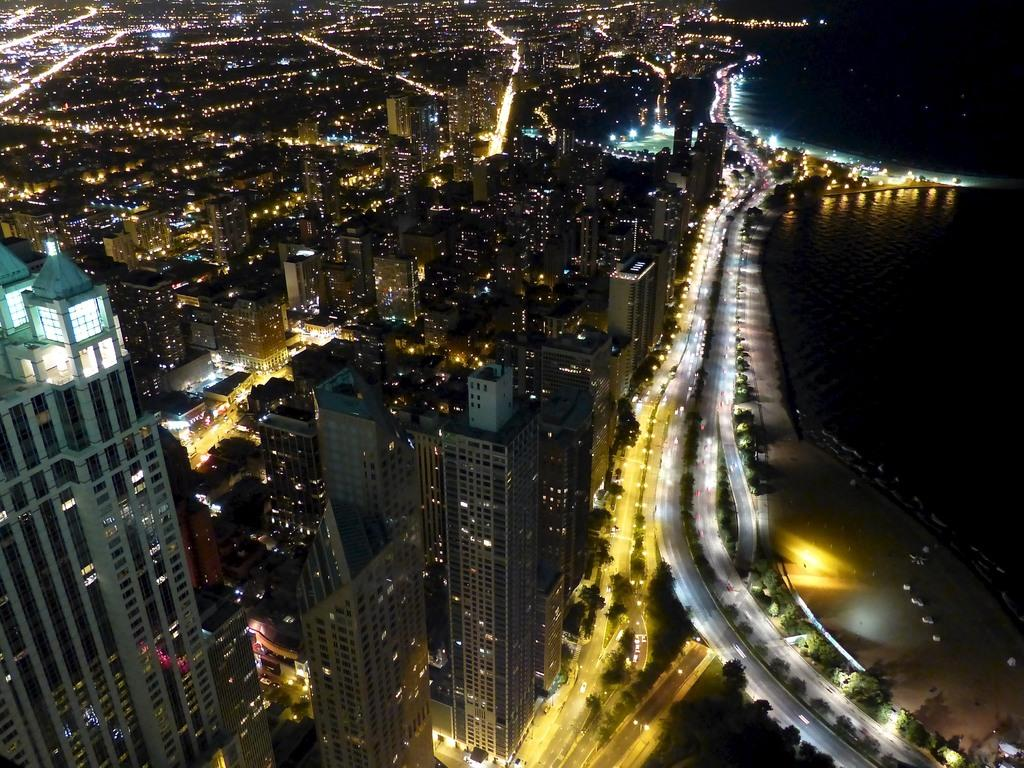What type of structures can be seen in the image? There are buildings in the image. What can be seen illuminated in the image? There are lights visible in the image. What type of transportation is present in the image? There are vehicles in the image. What natural element is on the right side of the image? There is water on the right side of the image. What type of vegetation is present in the image? There are trees in the image. What type of vein is visible in the image? There is no vein present in the image. What topic is being discussed in the image? There is no discussion taking place in the image. 